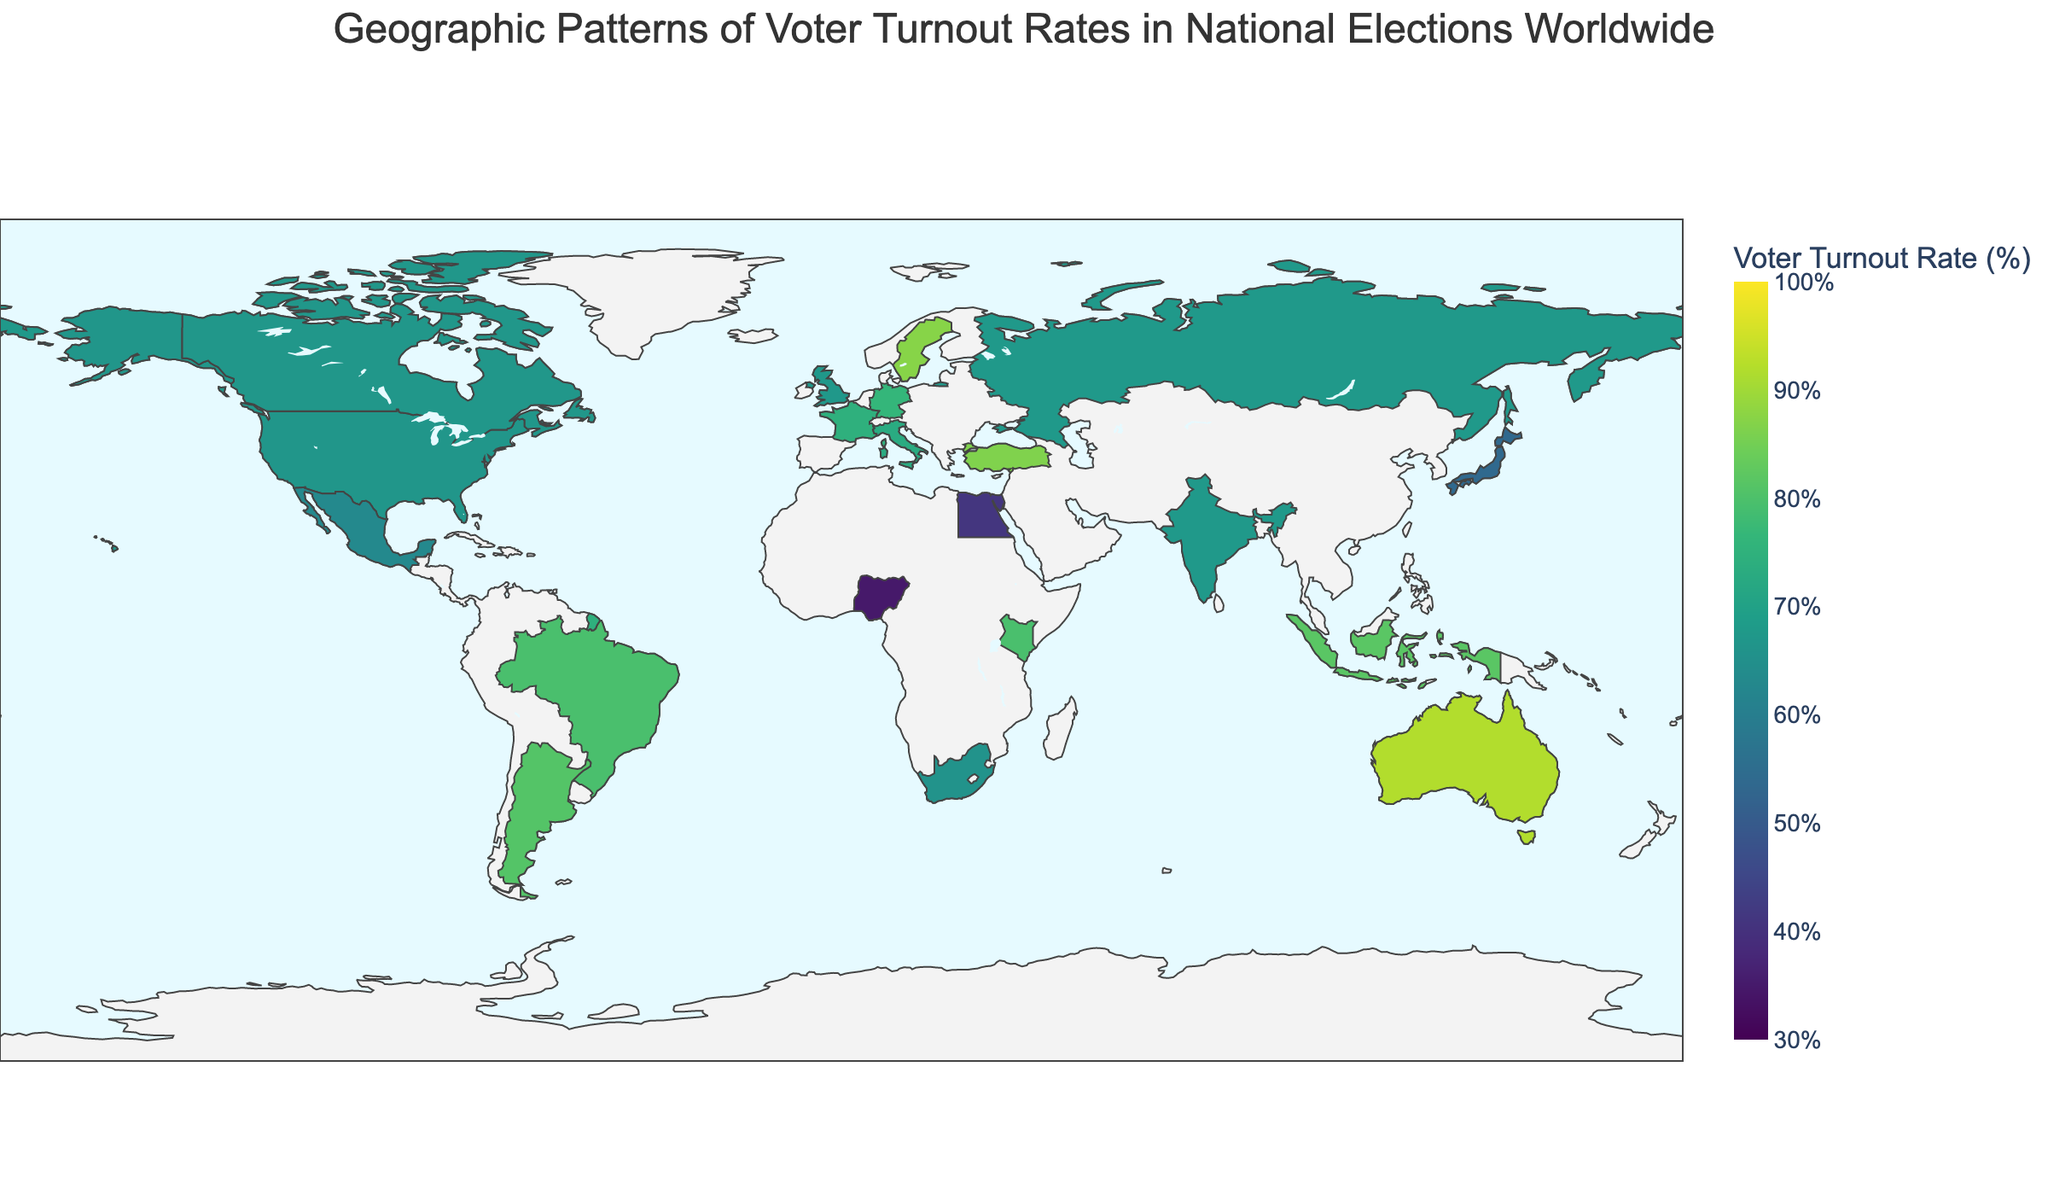Which country has the highest voter turnout rate? Observe the country with the highest color intensity on the map and refer to the hover data to confirm.
Answer: Australia Which region shows the lowest voter turnout rate on the map? Look for the region with the lightest color intensity and consult the voter turnout rates. North Africa has the lowest turnout rate with Egypt at 41.1%.
Answer: North Africa What is the voter turnout rate for India? Find India on the map and refer to the hover data to confirm.
Answer: 67.4 Which countries in Western Europe have their voter turnout rates shown? Identify the Western European countries highlighted on the map.
Answer: Germany, France, United Kingdom Which country in Africa has the highest voter turnout rate? Compare the voter turnout rates of African countries highlighted on the map.
Answer: Kenya Is the voter turnout rate in the United States higher or lower than in Germany? Compare the color intensity between the United States and Germany regions and refer to the hover data.
Answer: Lower What is the average voter turnout rate for South America? Identify the South American countries in the dataset, sum their voter turnout rates, and divide by the number of countries. Brazil (79.5) + Argentina (80.9) = 160.4, divide by 2.
Answer: 80.2 How does the voter turnout rate in Japan compare to that in Australia? Compare the voter turnout rates by observing the color intensity and referring to the hover data for Japan and Australia.
Answer: Lower Out of the countries shown, which region tends to have higher voter turnout rates: Europe or Asia? Compare European and Asian country turnouts by observing clusters of higher intensities and consulting their rates. Europe (Germany 76.2, France 74.6, Sweden 87.2, UK 67.3, Italy 72.9, Russia 67.5, Turkey 86.4) has higher rates compared to Asia (Japan 53.7, India 67.4, Indonesia 81.7).
Answer: Europe 